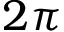Convert formula to latex. <formula><loc_0><loc_0><loc_500><loc_500>2 \pi</formula> 